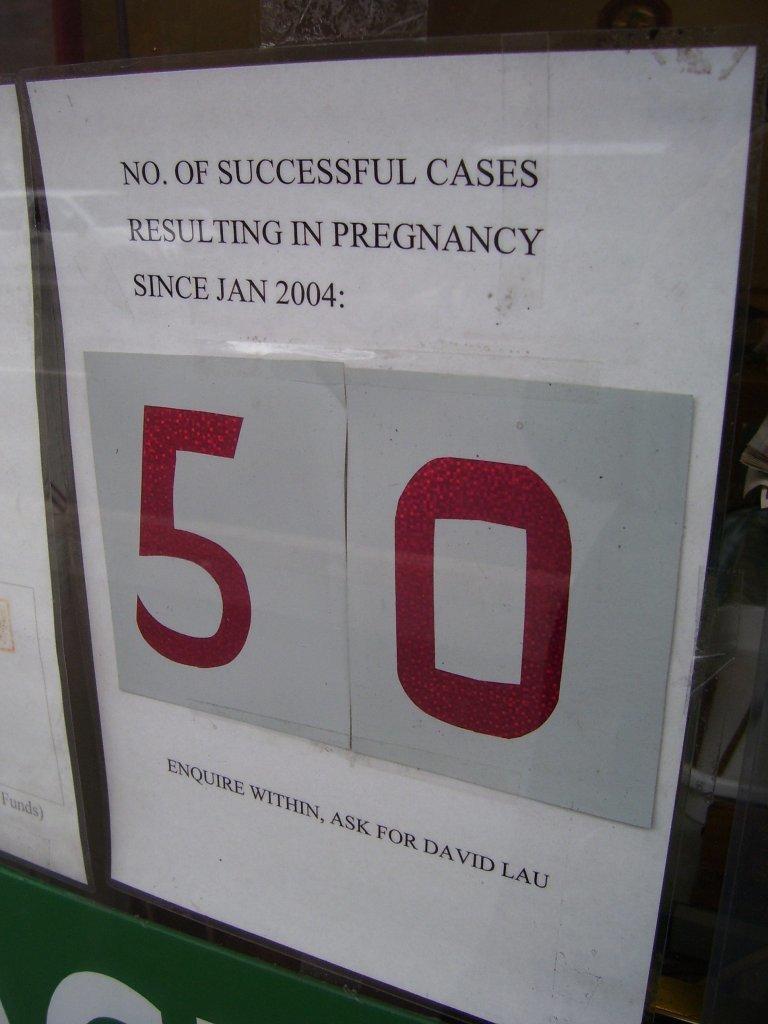Is this a astatistic?
Provide a succinct answer. Yes. Who should we contact for details?
Make the answer very short. David lau. 